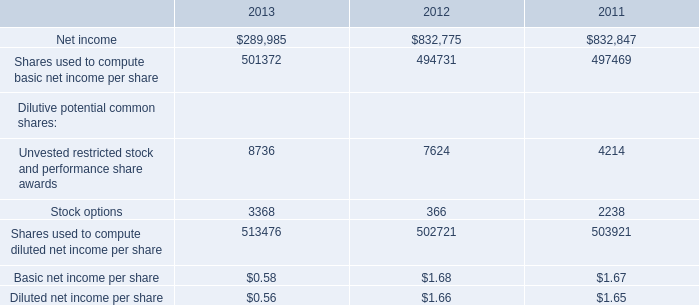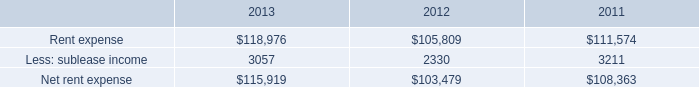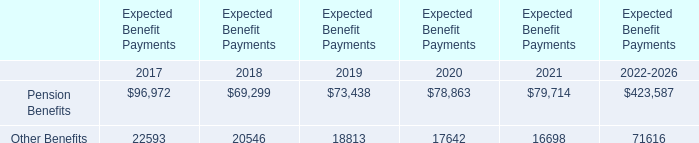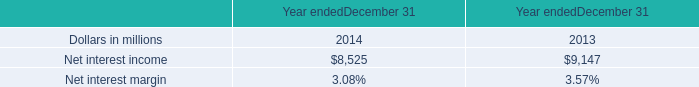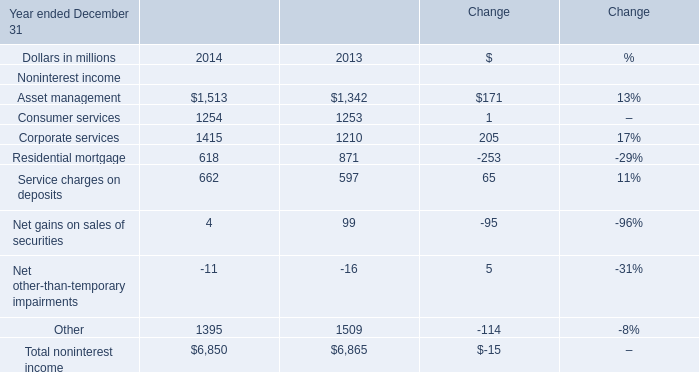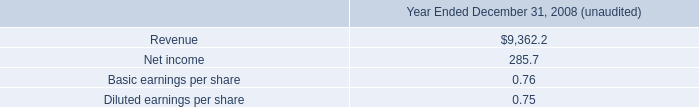what was the ratio of the restructuring and integration charges related to our integration of allied for 2009 to 2010 
Computations: (63.2 / 11.4)
Answer: 5.54386. 